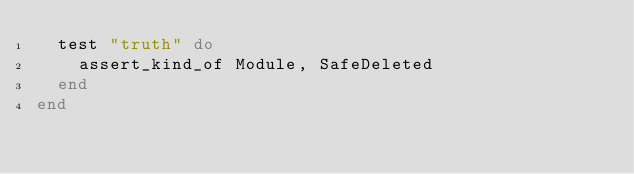<code> <loc_0><loc_0><loc_500><loc_500><_Ruby_>  test "truth" do
    assert_kind_of Module, SafeDeleted
  end
end
</code> 